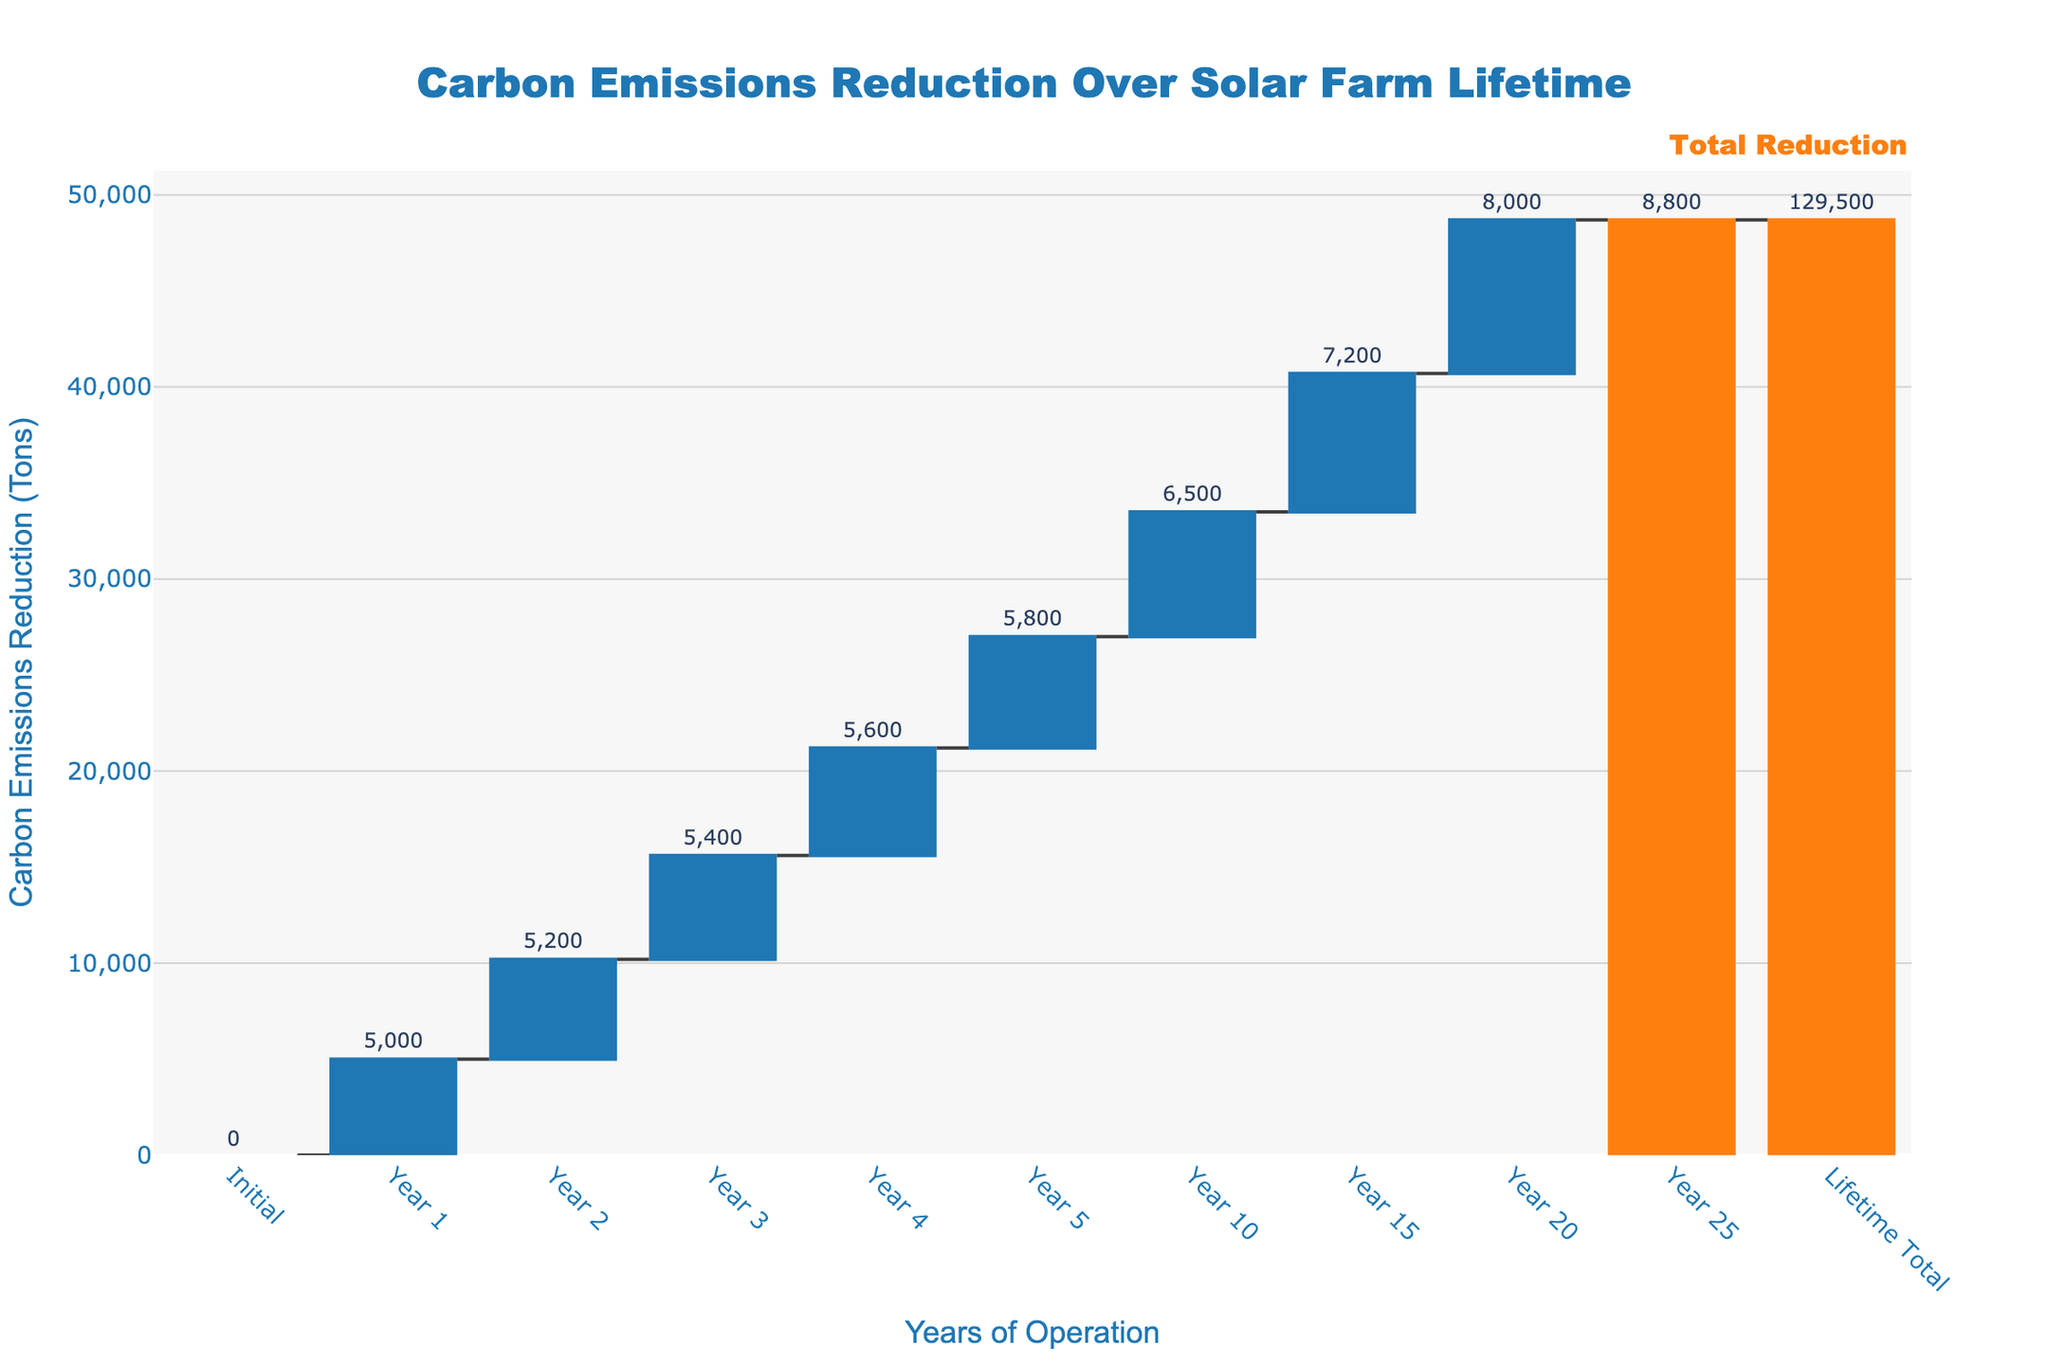What is the title of the figure? The title is located at the top center of the figure in large, bold font.
Answer: Carbon Emissions Reduction Over Solar Farm Lifetime How many years are depicted in the chart excluding the initial and final totals? The x-axis shows the different years of operation. We can count the unique labels excluding "Initial" and "Lifetime Total." These years are Year 1, Year 2, Year 3, Year 4, Year 5, Year 10, Year 15, and Year 20, making a total of 8 years.
Answer: 8 years What is the total carbon emissions reduction achieved by the solar farm over its lifetime, according to the chart? The total carbon emissions reduction can be found at the end of the chart under "Lifetime Total," which is also highlighted in a different color.
Answer: 129,500 tons How does the carbon emissions reduction in Year 10 compare to Year 5? By looking at the individual bars for Year 10 and Year 5, we see that Year 10 has a higher carbon emissions reduction. Year 5 shows 5,800 tons, while Year 10 shows 6,500 tons.
Answer: Year 10 has 700 more tons reduction What is the cumulative carbon emissions reduction by the end of Year 5? Add up the values from "Year 1" to "Year 5." These values are 5,000 + 5,200 + 5,400 + 5,600 + 5,800. The cumulative sum up to Year 5 would be 27,000 tons.
Answer: 27,000 tons Which year between Year 1 and Year 5 had the highest increment in carbon emissions reduction? We examine the incremental reductions for each year: Year 1: 5,000, Year 2: 5,200, Year 3: 5,400, Year 4: 5,600, Year 5: 5,800. Year 5 had the largest increment since it has the highest value among the five years.
Answer: Year 5 What color represents the total reduction in the figures? Observing the color coding, the totals are indicated by a distinct color.
Answer: Orange Which year saw the smallest increase in carbon emissions reduction compared to the previous year? Compare the year-on-year increases: Year 1 to Year 2 (5,200 - 5,000 = 200), Year 2 to Year 3 (5,400 - 5,200 = 200), Year 3 to Year 4 (5,600 - 5,400 = 200), and Year 4 to Year 5 (5,800 - 5,600 = 200). All these years saw the same increase of 200 tons.
Answer: Years 1, 2, 3, and 4 What is the average annual carbon emissions reduction from Year 1 to Year 5? Sum the annual reductions from Year 1 to Year 5, which are 5,000 + 5,200 + 5,400 + 5,600 + 5,800, and then divide by the number of years, 5. The total is 27,000, so the average is 27,000 / 5.
Answer: 5,400 tons How does the carbon emissions reduction for Year 20 compare to Year 15? Observing the bars for Year 20 and Year 15, Year 20 shows 8,000 tons and Year 15 shows 7,200 tons. Comparing these two values shows that Year 20 has more reduction by 800 tons.
Answer: Year 20 has 800 more tons reduction 